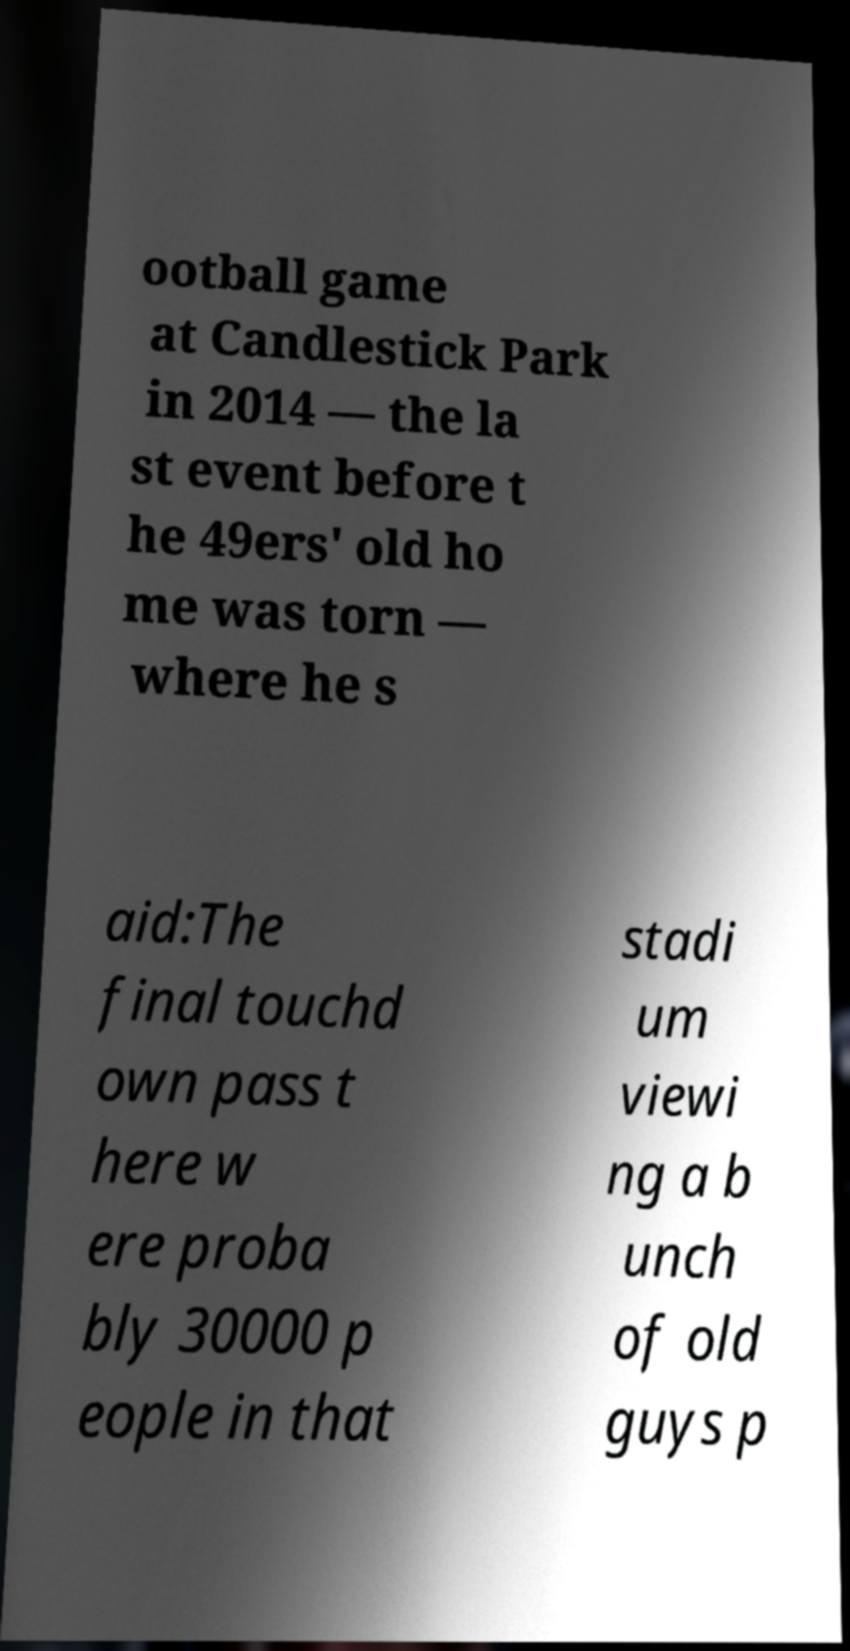There's text embedded in this image that I need extracted. Can you transcribe it verbatim? ootball game at Candlestick Park in 2014 — the la st event before t he 49ers' old ho me was torn — where he s aid:The final touchd own pass t here w ere proba bly 30000 p eople in that stadi um viewi ng a b unch of old guys p 